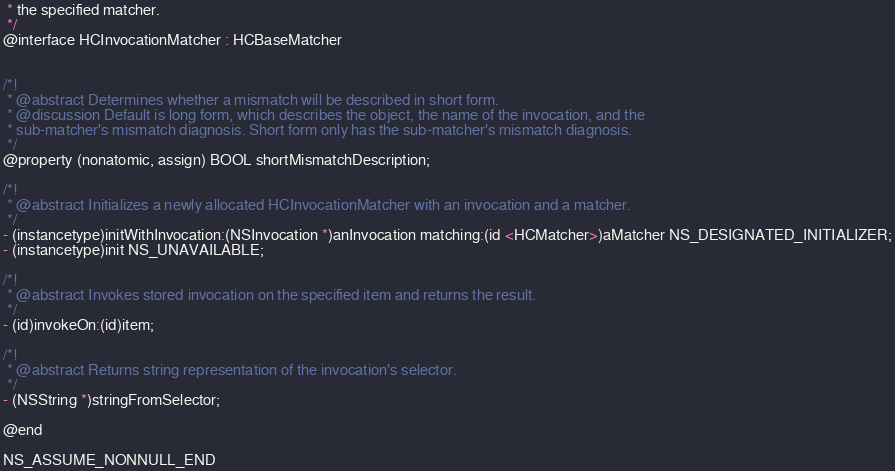<code> <loc_0><loc_0><loc_500><loc_500><_C_> * the specified matcher.
 */
@interface HCInvocationMatcher : HCBaseMatcher


/*!
 * @abstract Determines whether a mismatch will be described in short form.
 * @discussion Default is long form, which describes the object, the name of the invocation, and the
 * sub-matcher's mismatch diagnosis. Short form only has the sub-matcher's mismatch diagnosis.
 */
@property (nonatomic, assign) BOOL shortMismatchDescription;

/*!
 * @abstract Initializes a newly allocated HCInvocationMatcher with an invocation and a matcher.
 */
- (instancetype)initWithInvocation:(NSInvocation *)anInvocation matching:(id <HCMatcher>)aMatcher NS_DESIGNATED_INITIALIZER;
- (instancetype)init NS_UNAVAILABLE;

/*!
 * @abstract Invokes stored invocation on the specified item and returns the result.
 */
- (id)invokeOn:(id)item;

/*!
 * @abstract Returns string representation of the invocation's selector.
 */
- (NSString *)stringFromSelector;

@end

NS_ASSUME_NONNULL_END
</code> 